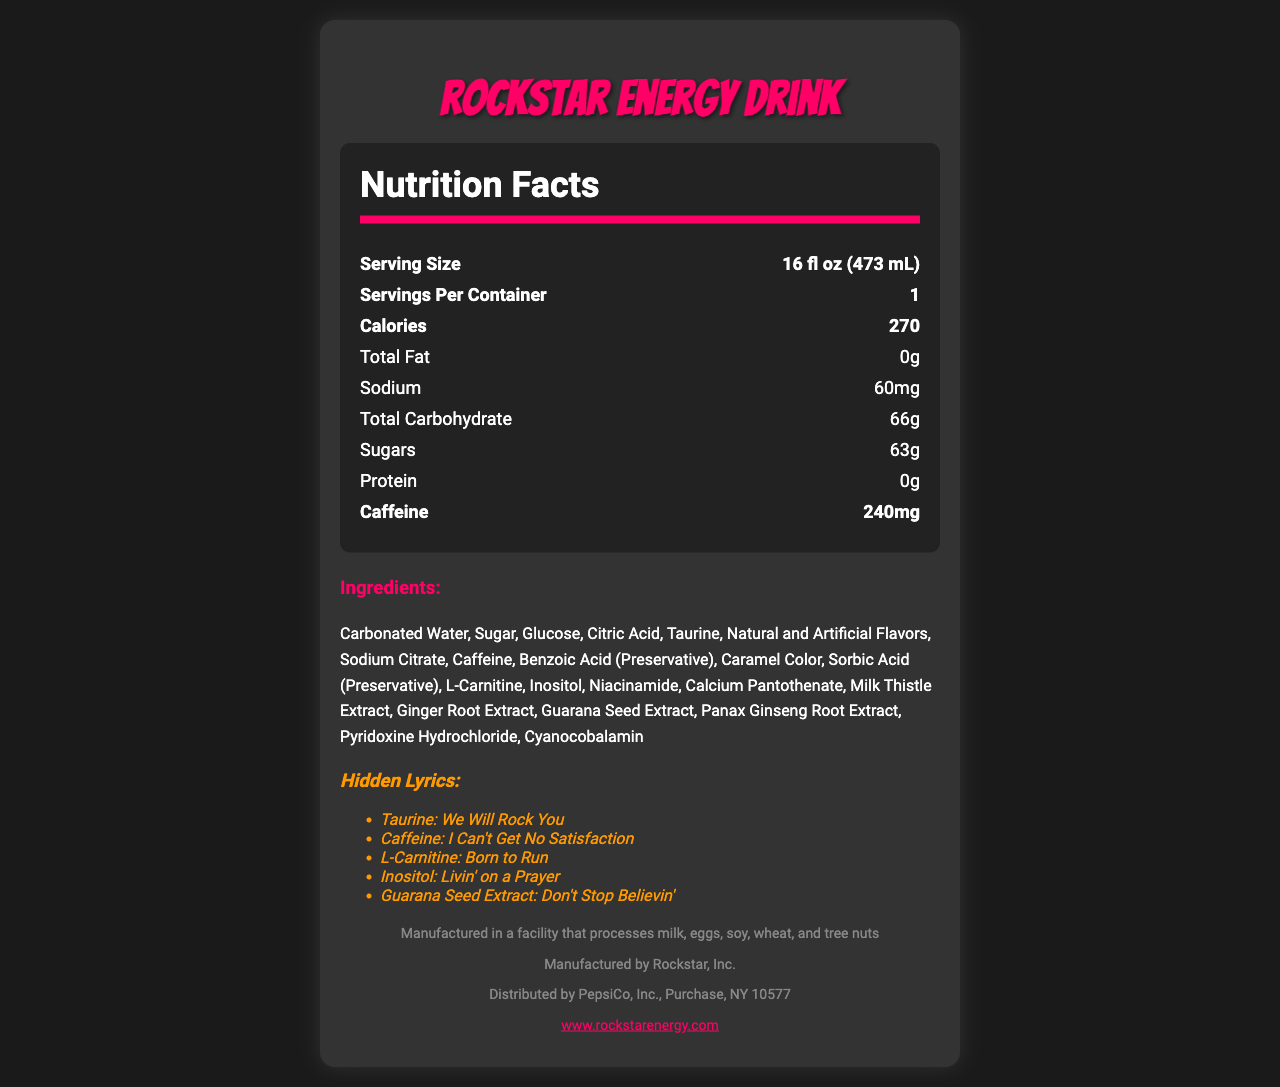What is the serving size of Rockstar Energy Drink? The serving size is explicitly stated as "16 fl oz (473 mL)" at the top of the nutrition facts.
Answer: 16 fl oz (473 mL) How many grams of total fat does the Rockstar Energy Drink contain? The nutrition facts section lists "Total Fat" as "0g".
Answer: 0g What is the amount of caffeine in one serving of Rockstar Energy Drink? The caffeine content is listed as "240mg" in the nutrition facts section.
Answer: 240mg Which vitamin is present in the amount of 6mcg in Rockstar Energy Drink? The nutrition facts section lists "Vitamin B12" with an amount of "6mcg".
Answer: Vitamin B12 Which ingredient in Rockstar Energy Drink has the hidden lyric "Livin' on a Prayer"? The list of hidden lyrics shows that Inositol is associated with the lyric "Livin' on a Prayer".
Answer: Inositol What is the manufacturer of Rockstar Energy Drink? The footer of the document indicates the manufacturer as "Rockstar, Inc."
Answer: Rockstar, Inc. Which entity distributes Rockstar Energy Drink? A. Coca-Cola B. PepsiCo C. Nestle D. Dr Pepper Snapple The footer of the document indicates that Rockstar Energy Drink is distributed by "PepsiCo, Inc."
Answer: B Which vitamin present in the drink contributes 100% to the daily value? I. Niacin II. Vitamin B6 III. Vitamin B12 IV. Pantothenic Acid V. All of the above The nutrition facts list Niacin, Vitamin B6, Vitamin B12, and Pantothenic Acid each with 100% daily value.
Answer: V Is this energy drink calorie-free? The drink has 270 calories as stated in the nutrition facts.
Answer: No Summarize the main nutrition and ingredient details of Rockstar Energy Drink. The summary captures the essential nutrient values and a handful of key ingredients, along with the presence of significant vitamins.
Answer: Rockstar Energy Drink contains 270 calories per serving, 0g total fat, 60mg sodium, 66g total carbohydrate, 63g sugars, 0g protein, and 240mg caffeine. It also provides 100% daily value of Niacin, Vitamin B6, Vitamin B12, and Pantothenic Acid. Main ingredients include Carbonated Water, Sugar, Caffeine, and various extracts. Does Rockstar Energy Drink contain any allergens? The document states that the drink is manufactured in a facility that processes milk, eggs, soy, wheat, and tree nuts but does not explicitly state if it contains these allergens.
Answer: Not enough information 